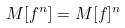<formula> <loc_0><loc_0><loc_500><loc_500>M [ f ^ { n } ] = M [ f ] ^ { n }</formula> 